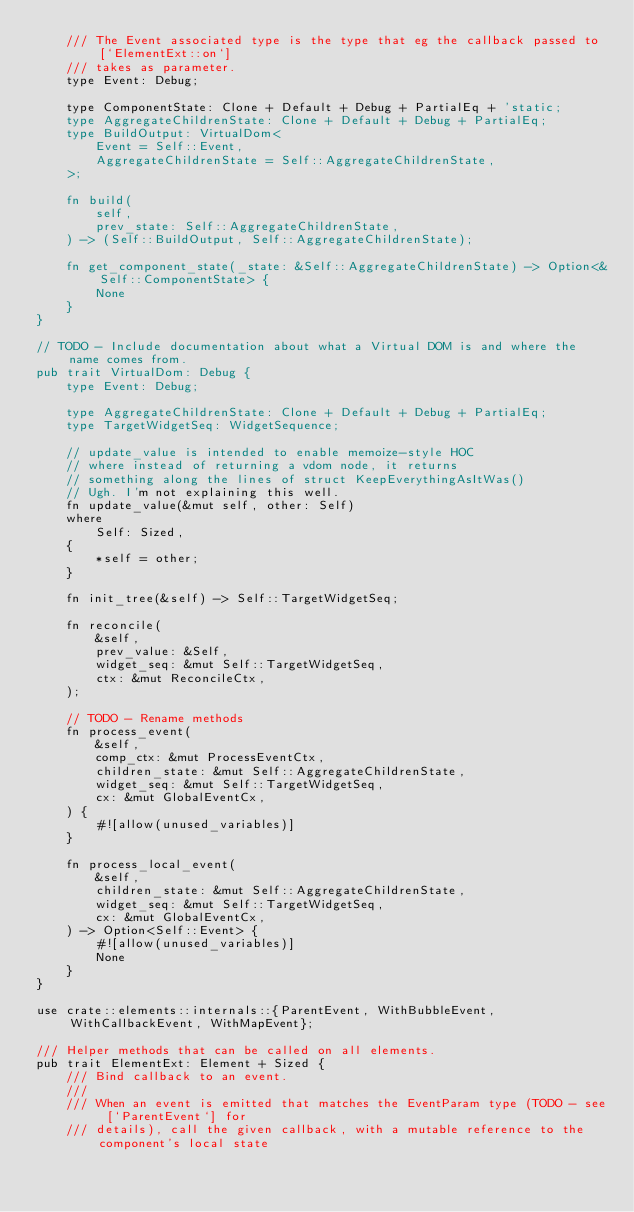Convert code to text. <code><loc_0><loc_0><loc_500><loc_500><_Rust_>    /// The Event associated type is the type that eg the callback passed to [`ElementExt::on`]
    /// takes as parameter.
    type Event: Debug;

    type ComponentState: Clone + Default + Debug + PartialEq + 'static;
    type AggregateChildrenState: Clone + Default + Debug + PartialEq;
    type BuildOutput: VirtualDom<
        Event = Self::Event,
        AggregateChildrenState = Self::AggregateChildrenState,
    >;

    fn build(
        self,
        prev_state: Self::AggregateChildrenState,
    ) -> (Self::BuildOutput, Self::AggregateChildrenState);

    fn get_component_state(_state: &Self::AggregateChildrenState) -> Option<&Self::ComponentState> {
        None
    }
}

// TODO - Include documentation about what a Virtual DOM is and where the name comes from.
pub trait VirtualDom: Debug {
    type Event: Debug;

    type AggregateChildrenState: Clone + Default + Debug + PartialEq;
    type TargetWidgetSeq: WidgetSequence;

    // update_value is intended to enable memoize-style HOC
    // where instead of returning a vdom node, it returns
    // something along the lines of struct KeepEverythingAsItWas()
    // Ugh. I'm not explaining this well.
    fn update_value(&mut self, other: Self)
    where
        Self: Sized,
    {
        *self = other;
    }

    fn init_tree(&self) -> Self::TargetWidgetSeq;

    fn reconcile(
        &self,
        prev_value: &Self,
        widget_seq: &mut Self::TargetWidgetSeq,
        ctx: &mut ReconcileCtx,
    );

    // TODO - Rename methods
    fn process_event(
        &self,
        comp_ctx: &mut ProcessEventCtx,
        children_state: &mut Self::AggregateChildrenState,
        widget_seq: &mut Self::TargetWidgetSeq,
        cx: &mut GlobalEventCx,
    ) {
        #![allow(unused_variables)]
    }

    fn process_local_event(
        &self,
        children_state: &mut Self::AggregateChildrenState,
        widget_seq: &mut Self::TargetWidgetSeq,
        cx: &mut GlobalEventCx,
    ) -> Option<Self::Event> {
        #![allow(unused_variables)]
        None
    }
}

use crate::elements::internals::{ParentEvent, WithBubbleEvent, WithCallbackEvent, WithMapEvent};

/// Helper methods that can be called on all elements.
pub trait ElementExt: Element + Sized {
    /// Bind callback to an event.
    ///
    /// When an event is emitted that matches the EventParam type (TODO - see [`ParentEvent`] for
    /// details), call the given callback, with a mutable reference to the component's local state</code> 